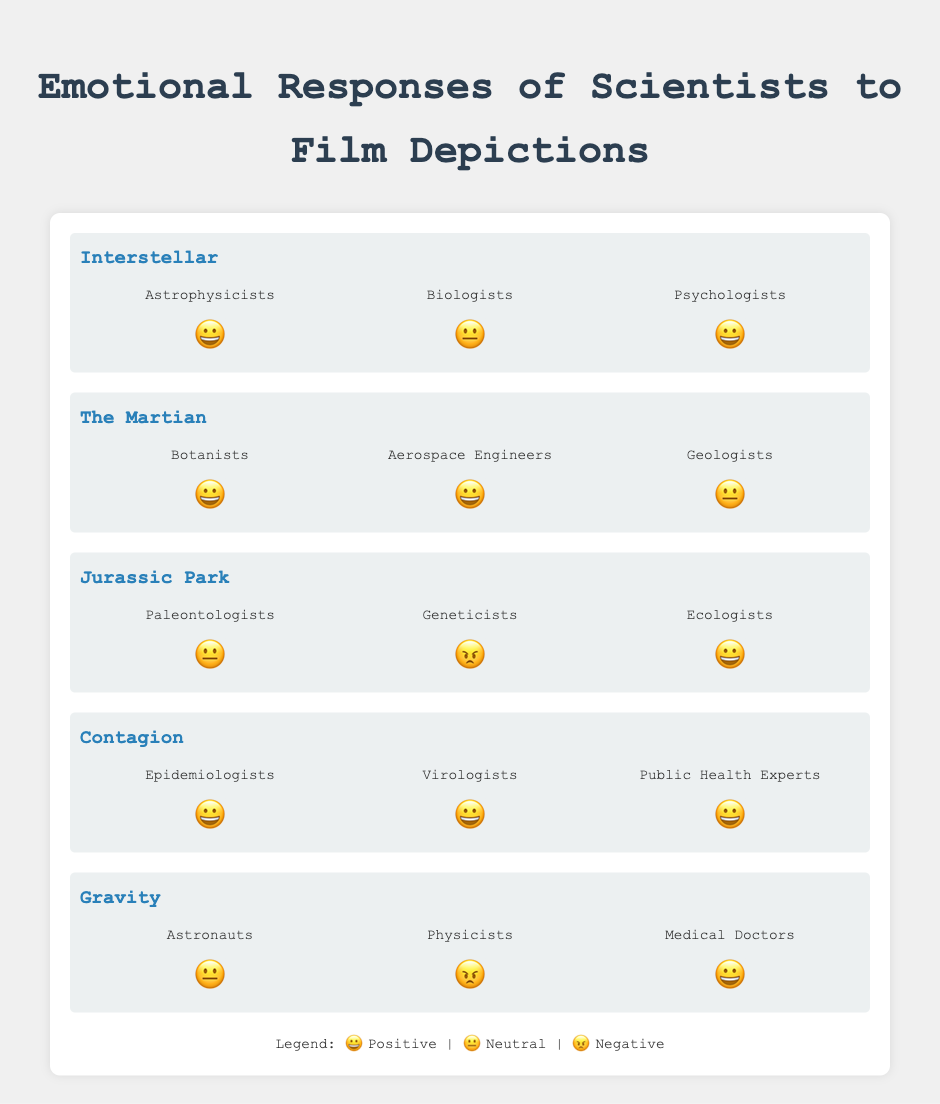Which film made paleontologists feel neutral? According to the figure, we need to identify the film where paleontologists' response is indicated by the neutral emoji 😐. For "Jurassic Park", paleontologists gave a neutral response.
Answer: Jurassic Park What was the emotional response of physicists to "Gravity"? We examine the film "Gravity" and find the emoji associated with physicists. They responded with 😠, which indicates a negative response.
Answer: 😠 Which film received positive responses from all scientists depicted? By looking through each film and checking for the positive emoji 😀 across all scientist categories, only "Contagion" shows all positive responses from epidemiologists, virologists, and public health experts.
Answer: Contagion How did ecologists feel about "Jurassic Park"? We find "Jurassic Park" and check the emoji next to ecologists. The response is 😀, indicating a positive response.
Answer: 😀 Compare the responses of astrophysicists and biologists to "Interstellar". For "Interstellar", astrophysicists gave a positive 😀 response, while biologists gave a neutral 😐 response.
Answer: Astrophysicists: 😀, Biologists: 😐 Which film had the most diverse emotional responses from scientists? By examining each film's spread of responses, "Jurassic Park" has the most diverse responses with 😐 from paleontologists, 😠 from geneticists, and 😀 from ecologists.
Answer: Jurassic Park What is the common response between psychologists for "Interstellar" and medical doctors for "Gravity"? Looking at the response for psychologists in "Interstellar" and medical doctors in "Gravity", both groups responded positively with 😀.
Answer: 😀 For "The Martian," which scientist group had a neutral reaction? Checking the emoji responses for "The Martian," geologists had a neutral 😐 reaction.
Answer: Geologists What is the overall sentiment of aerospace engineers towards "The Martian"? Referring to the figure, aerospace engineers responded to "The Martian" with the positive 😀 emoji.
Answer: 😀 